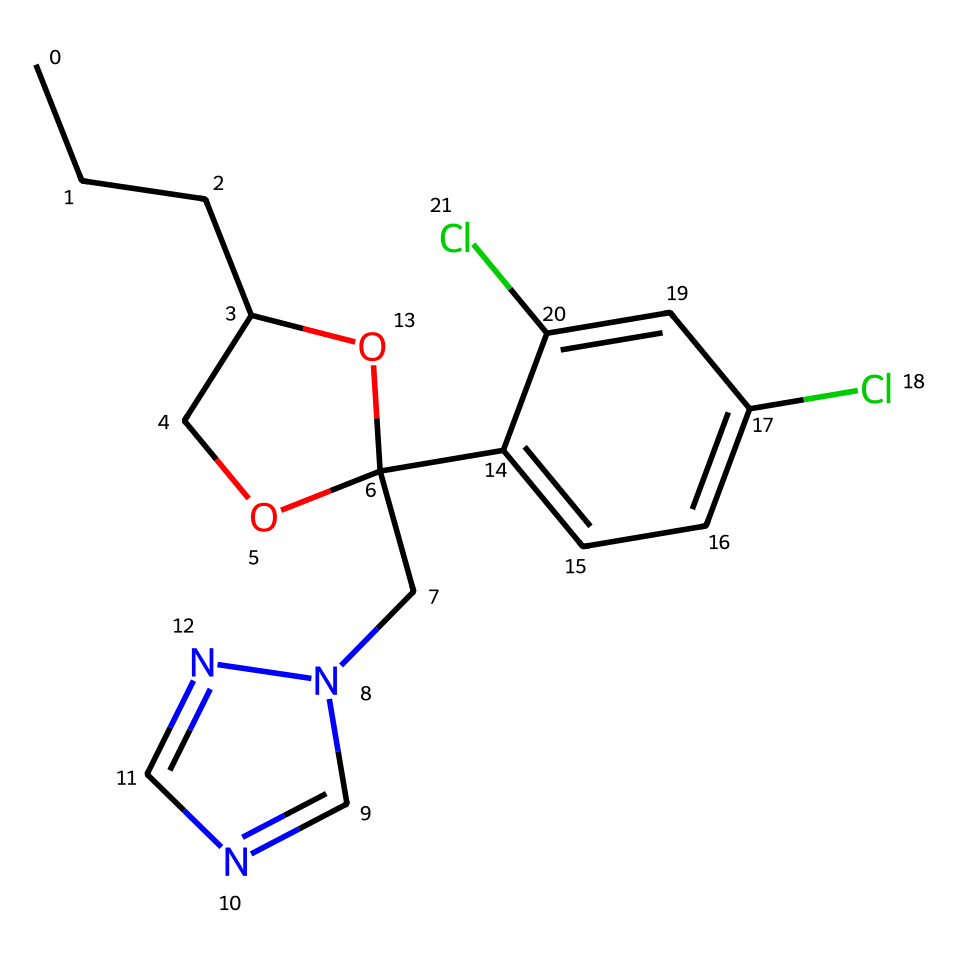How many chlorine atoms are present in the chemical structure? Counting the chlorine (Cl) symbols in the SMILES representation, there are two instances of Cl, indicating two chlorine atoms in the structure.
Answer: two What is the main functional group of this chemical? Analyzing the structure, the presence of a hydroxyl group (-OH) is indicated by the "O" followed by a bond to a carbon atom, which is characteristic of alcohols.
Answer: hydroxyl What type of chemical is propiconazole classified as? Based on its structure and known properties, propiconazole is identified as a triazole fungicide due to the presence of the triazole ring (the nitrogen atoms in the ring).
Answer: triazole fungicide How many carbon atoms are present in the structure? By counting the "C" in the SMILES string and considering the different branches shown, the total number of carbon atoms in the structure is calculated to be 15.
Answer: fifteen What type of bonds are primarily present in this chemical? The structure primarily contains single bonds between carbon atoms and other atoms, as evidenced by the absence of double bond symbols in the given SMILES string.
Answer: single Which element in the structure may influence bird habitats adversely? The chemical contains chlorine atoms, which, when released into the environment, can have detrimental effects on wildlife and bird habitats.
Answer: chlorine 